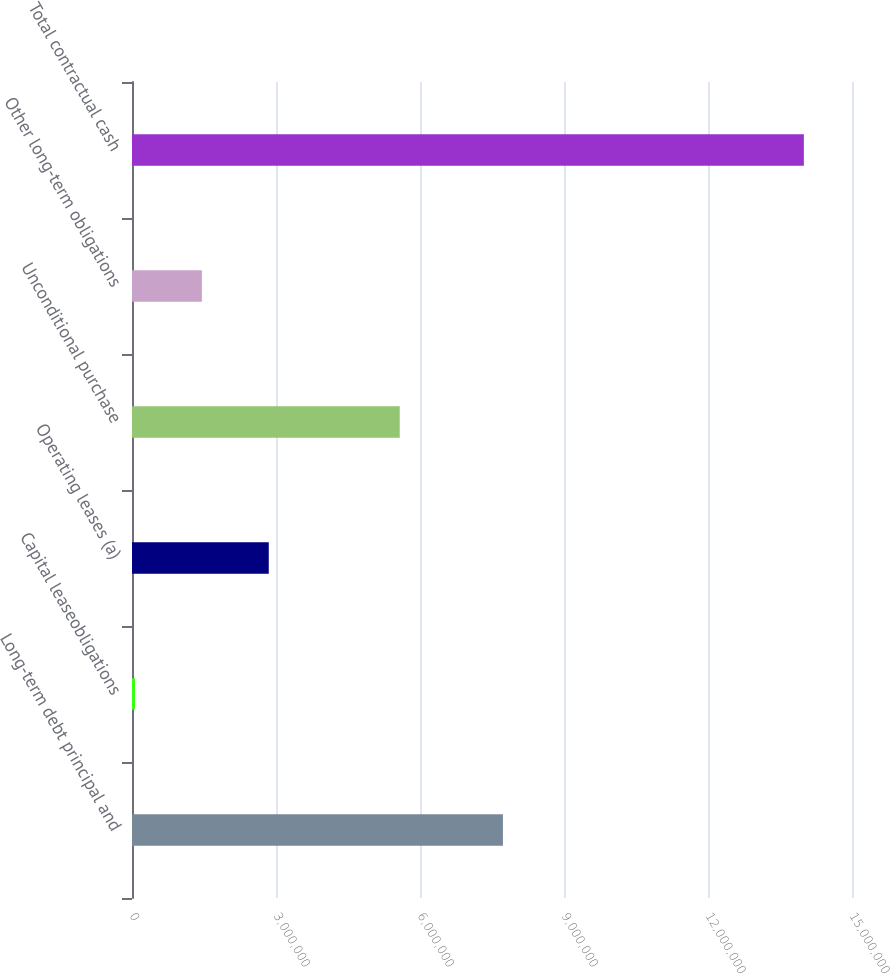<chart> <loc_0><loc_0><loc_500><loc_500><bar_chart><fcel>Long-term debt principal and<fcel>Capital leaseobligations<fcel>Operating leases (a)<fcel>Unconditional purchase<fcel>Other long-term obligations<fcel>Total contractual cash<nl><fcel>7.72784e+06<fcel>62365<fcel>2.84933e+06<fcel>5.57772e+06<fcel>1.45585e+06<fcel>1.39972e+07<nl></chart> 